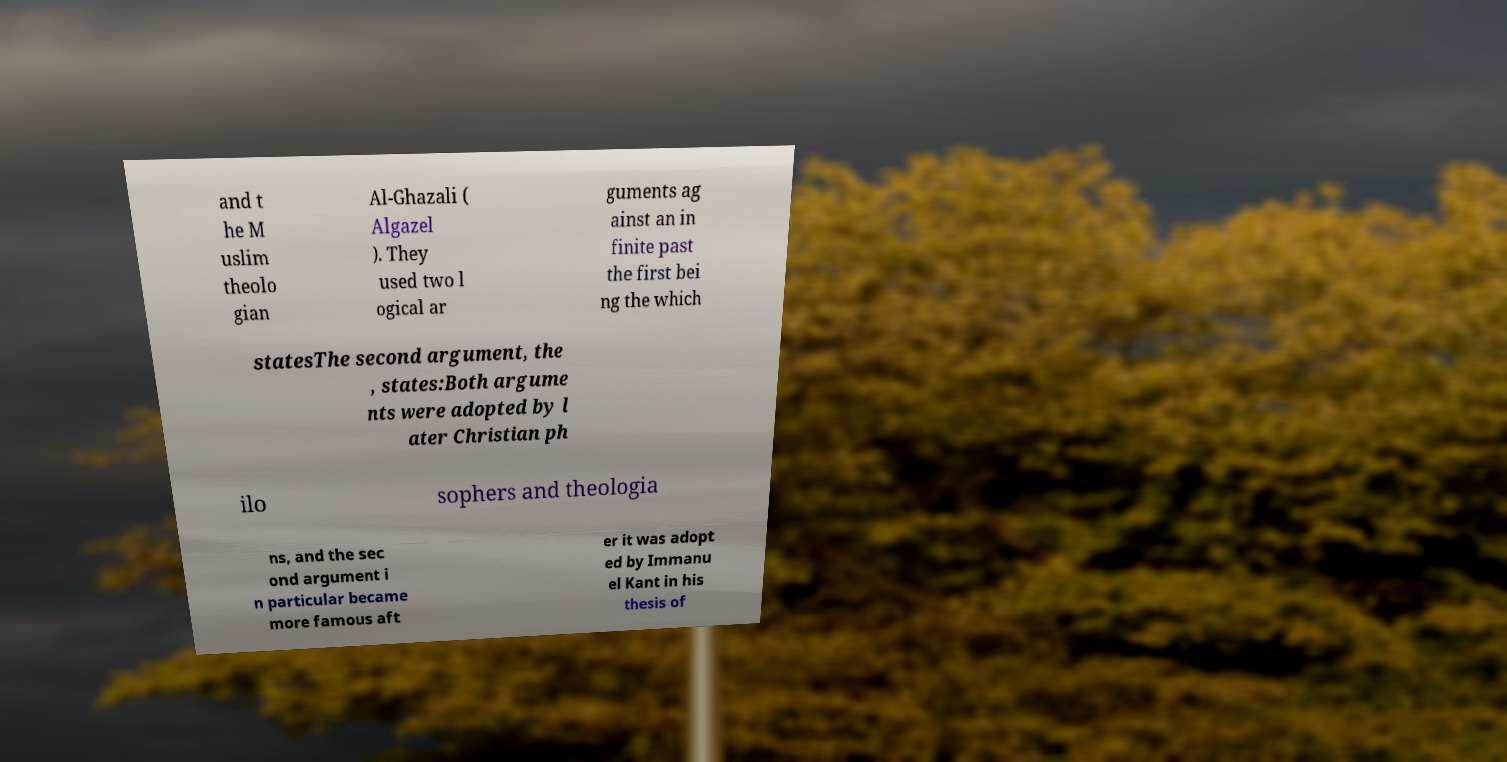Can you read and provide the text displayed in the image?This photo seems to have some interesting text. Can you extract and type it out for me? and t he M uslim theolo gian Al-Ghazali ( Algazel ). They used two l ogical ar guments ag ainst an in finite past the first bei ng the which statesThe second argument, the , states:Both argume nts were adopted by l ater Christian ph ilo sophers and theologia ns, and the sec ond argument i n particular became more famous aft er it was adopt ed by Immanu el Kant in his thesis of 